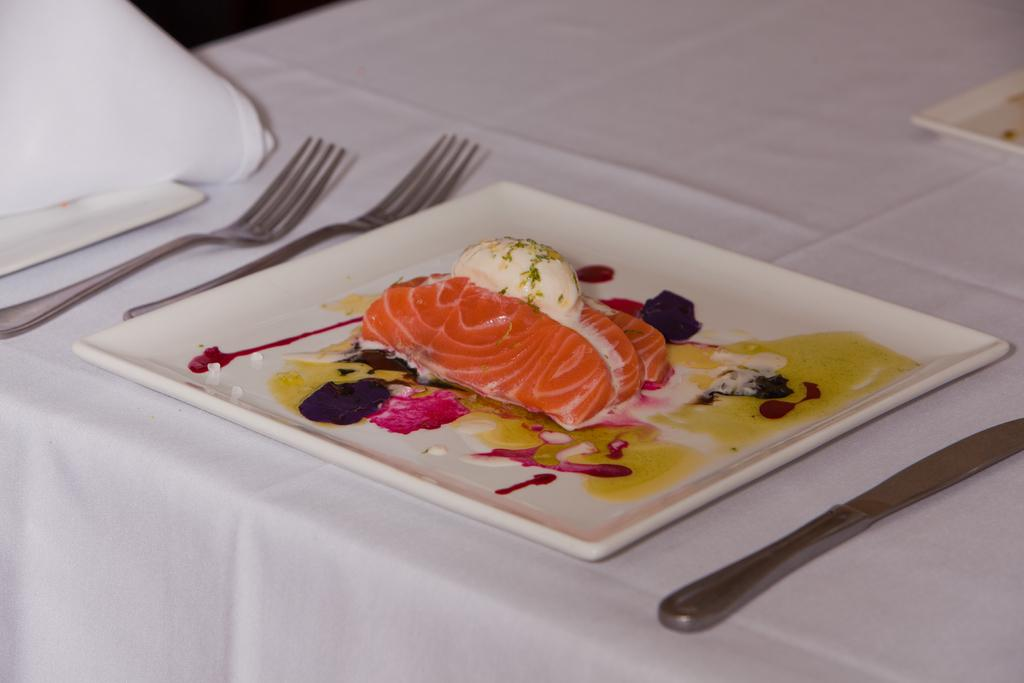What type of food can be seen in the image? The food in the image has white and orange colors. How is the food arranged in the image? The food is on a plate. What color is the plate? The plate is white. How many forks are visible in the image? There are two forks in the image. Where are the forks placed in the image? The forks are on a white cloth. Can you see any dolls playing with mice in the image? There are no dolls or mice present in the image. 